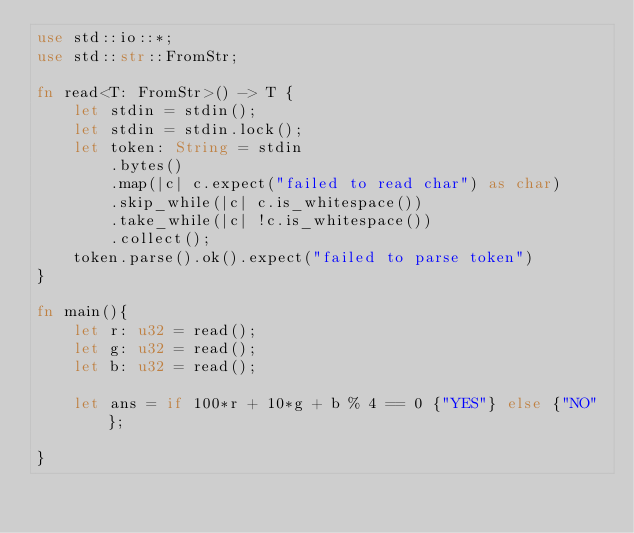<code> <loc_0><loc_0><loc_500><loc_500><_Rust_>use std::io::*;
use std::str::FromStr;

fn read<T: FromStr>() -> T {
    let stdin = stdin();
    let stdin = stdin.lock();
    let token: String = stdin
        .bytes()
        .map(|c| c.expect("failed to read char") as char) 
        .skip_while(|c| c.is_whitespace())
        .take_while(|c| !c.is_whitespace())
        .collect();
    token.parse().ok().expect("failed to parse token")
}

fn main(){
	let r: u32 = read();
    let g: u32 = read();
    let b: u32 = read();
	
	let ans = if 100*r + 10*g + b % 4 == 0 {"YES"} else {"NO"};
   
}</code> 